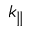Convert formula to latex. <formula><loc_0><loc_0><loc_500><loc_500>k _ { \| }</formula> 